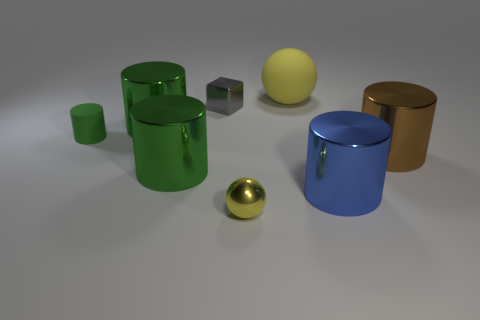Subtract all green cylinders. How many were subtracted if there are1green cylinders left? 2 Subtract all brown metal cylinders. How many cylinders are left? 4 Add 2 large purple cubes. How many objects exist? 10 Subtract all blue cylinders. How many cylinders are left? 4 Subtract 1 cubes. How many cubes are left? 0 Subtract all purple cubes. How many green cylinders are left? 3 Subtract all spheres. How many objects are left? 6 Subtract all gray metallic objects. Subtract all small green things. How many objects are left? 6 Add 4 big blue metallic objects. How many big blue metallic objects are left? 5 Add 5 brown rubber balls. How many brown rubber balls exist? 5 